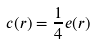Convert formula to latex. <formula><loc_0><loc_0><loc_500><loc_500>c ( r ) = \frac { 1 } { 4 } e ( r )</formula> 